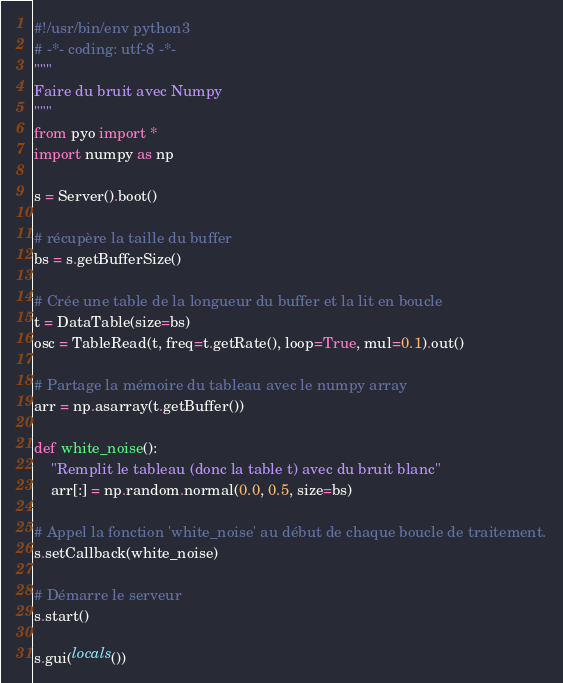Convert code to text. <code><loc_0><loc_0><loc_500><loc_500><_Python_>#!/usr/bin/env python3
# -*- coding: utf-8 -*-
"""
Faire du bruit avec Numpy
"""
from pyo import *
import numpy as np

s = Server().boot()

# récupère la taille du buffer
bs = s.getBufferSize()

# Crée une table de la longueur du buffer et la lit en boucle
t = DataTable(size=bs)
osc = TableRead(t, freq=t.getRate(), loop=True, mul=0.1).out()

# Partage la mémoire du tableau avec le numpy array
arr = np.asarray(t.getBuffer())

def white_noise():
    "Remplit le tableau (donc la table t) avec du bruit blanc"
    arr[:] = np.random.normal(0.0, 0.5, size=bs)

# Appel la fonction 'white_noise' au début de chaque boucle de traitement.
s.setCallback(white_noise)

# Démarre le serveur
s.start()

s.gui(locals())
</code> 